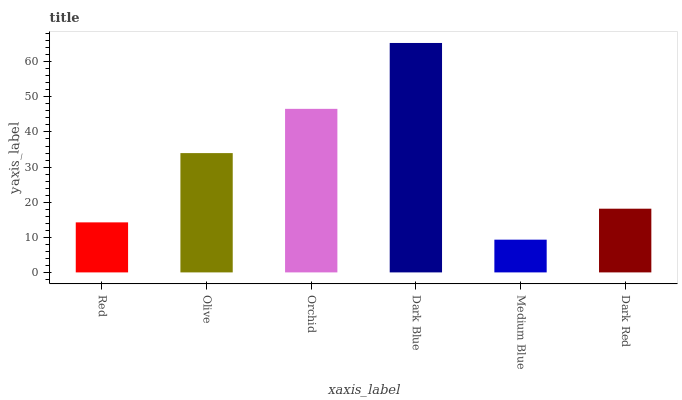Is Medium Blue the minimum?
Answer yes or no. Yes. Is Dark Blue the maximum?
Answer yes or no. Yes. Is Olive the minimum?
Answer yes or no. No. Is Olive the maximum?
Answer yes or no. No. Is Olive greater than Red?
Answer yes or no. Yes. Is Red less than Olive?
Answer yes or no. Yes. Is Red greater than Olive?
Answer yes or no. No. Is Olive less than Red?
Answer yes or no. No. Is Olive the high median?
Answer yes or no. Yes. Is Dark Red the low median?
Answer yes or no. Yes. Is Dark Blue the high median?
Answer yes or no. No. Is Medium Blue the low median?
Answer yes or no. No. 